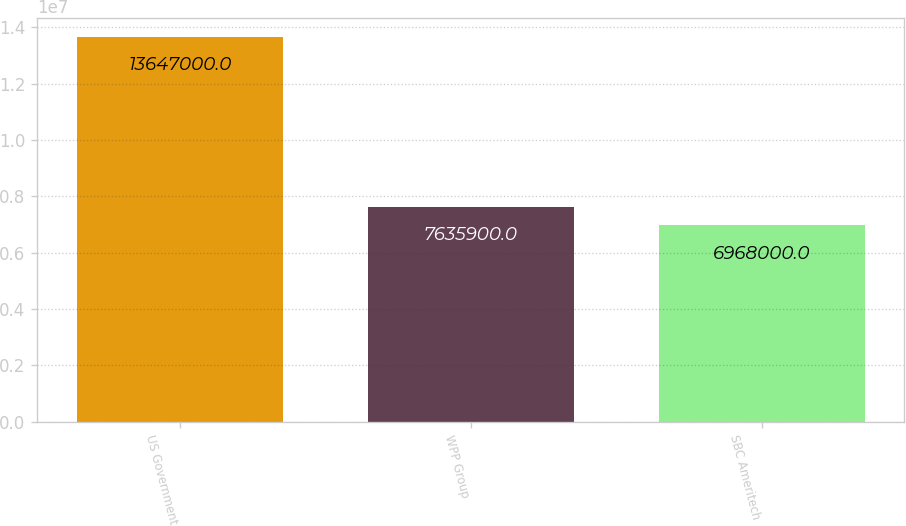Convert chart. <chart><loc_0><loc_0><loc_500><loc_500><bar_chart><fcel>US Government<fcel>WPP Group<fcel>SBC Ameritech<nl><fcel>1.3647e+07<fcel>7.6359e+06<fcel>6.968e+06<nl></chart> 